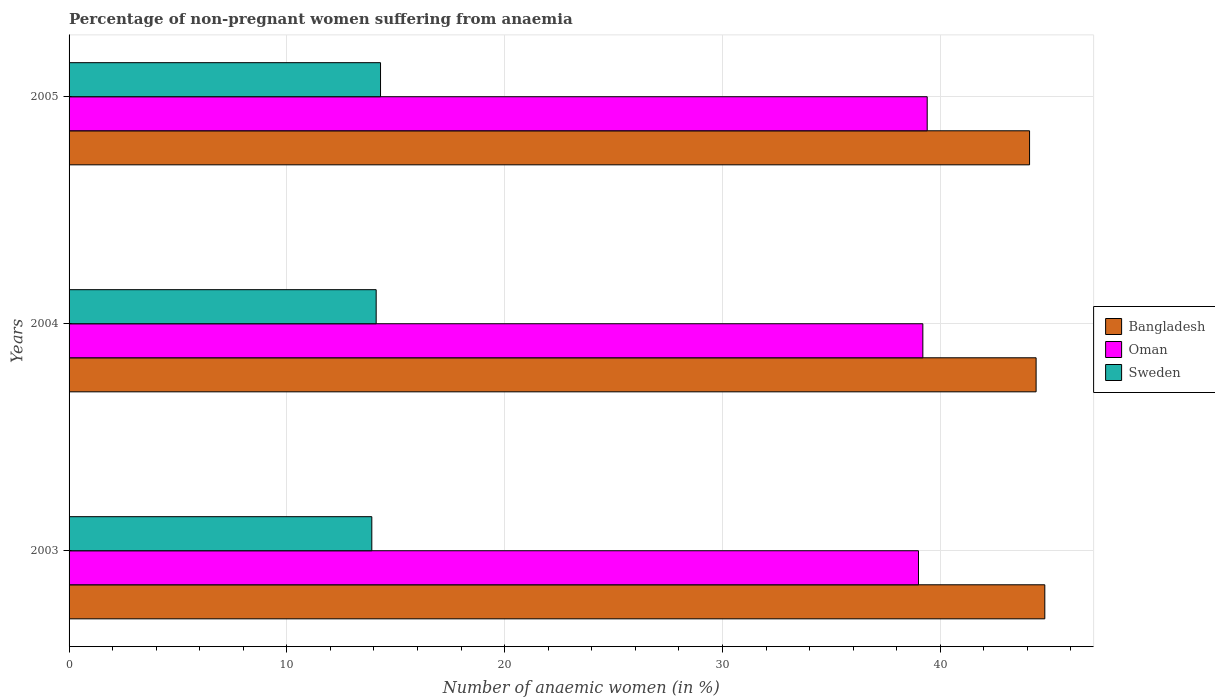Are the number of bars per tick equal to the number of legend labels?
Provide a short and direct response. Yes. How many bars are there on the 3rd tick from the bottom?
Keep it short and to the point. 3. In how many cases, is the number of bars for a given year not equal to the number of legend labels?
Keep it short and to the point. 0. What is the percentage of non-pregnant women suffering from anaemia in Oman in 2004?
Provide a succinct answer. 39.2. Across all years, what is the maximum percentage of non-pregnant women suffering from anaemia in Sweden?
Offer a very short reply. 14.3. In which year was the percentage of non-pregnant women suffering from anaemia in Sweden maximum?
Offer a very short reply. 2005. In which year was the percentage of non-pregnant women suffering from anaemia in Sweden minimum?
Provide a short and direct response. 2003. What is the total percentage of non-pregnant women suffering from anaemia in Bangladesh in the graph?
Your answer should be very brief. 133.3. What is the difference between the percentage of non-pregnant women suffering from anaemia in Bangladesh in 2003 and that in 2004?
Make the answer very short. 0.4. What is the difference between the percentage of non-pregnant women suffering from anaemia in Bangladesh in 2005 and the percentage of non-pregnant women suffering from anaemia in Sweden in 2003?
Provide a short and direct response. 30.2. What is the average percentage of non-pregnant women suffering from anaemia in Bangladesh per year?
Give a very brief answer. 44.43. In the year 2005, what is the difference between the percentage of non-pregnant women suffering from anaemia in Sweden and percentage of non-pregnant women suffering from anaemia in Bangladesh?
Provide a short and direct response. -29.8. In how many years, is the percentage of non-pregnant women suffering from anaemia in Oman greater than 10 %?
Your answer should be very brief. 3. What is the ratio of the percentage of non-pregnant women suffering from anaemia in Sweden in 2003 to that in 2005?
Keep it short and to the point. 0.97. Is the difference between the percentage of non-pregnant women suffering from anaemia in Sweden in 2004 and 2005 greater than the difference between the percentage of non-pregnant women suffering from anaemia in Bangladesh in 2004 and 2005?
Provide a succinct answer. No. What is the difference between the highest and the second highest percentage of non-pregnant women suffering from anaemia in Bangladesh?
Make the answer very short. 0.4. What is the difference between the highest and the lowest percentage of non-pregnant women suffering from anaemia in Oman?
Provide a succinct answer. 0.4. Is the sum of the percentage of non-pregnant women suffering from anaemia in Oman in 2003 and 2005 greater than the maximum percentage of non-pregnant women suffering from anaemia in Bangladesh across all years?
Ensure brevity in your answer.  Yes. What does the 1st bar from the bottom in 2003 represents?
Offer a terse response. Bangladesh. Are all the bars in the graph horizontal?
Give a very brief answer. Yes. Are the values on the major ticks of X-axis written in scientific E-notation?
Offer a terse response. No. Does the graph contain any zero values?
Ensure brevity in your answer.  No. What is the title of the graph?
Offer a very short reply. Percentage of non-pregnant women suffering from anaemia. Does "Andorra" appear as one of the legend labels in the graph?
Your answer should be very brief. No. What is the label or title of the X-axis?
Provide a short and direct response. Number of anaemic women (in %). What is the label or title of the Y-axis?
Your answer should be compact. Years. What is the Number of anaemic women (in %) in Bangladesh in 2003?
Ensure brevity in your answer.  44.8. What is the Number of anaemic women (in %) of Oman in 2003?
Your answer should be compact. 39. What is the Number of anaemic women (in %) in Sweden in 2003?
Give a very brief answer. 13.9. What is the Number of anaemic women (in %) in Bangladesh in 2004?
Your response must be concise. 44.4. What is the Number of anaemic women (in %) in Oman in 2004?
Your response must be concise. 39.2. What is the Number of anaemic women (in %) of Sweden in 2004?
Your response must be concise. 14.1. What is the Number of anaemic women (in %) in Bangladesh in 2005?
Your answer should be very brief. 44.1. What is the Number of anaemic women (in %) of Oman in 2005?
Provide a succinct answer. 39.4. What is the Number of anaemic women (in %) of Sweden in 2005?
Your answer should be very brief. 14.3. Across all years, what is the maximum Number of anaemic women (in %) in Bangladesh?
Provide a succinct answer. 44.8. Across all years, what is the maximum Number of anaemic women (in %) of Oman?
Provide a short and direct response. 39.4. Across all years, what is the minimum Number of anaemic women (in %) in Bangladesh?
Your response must be concise. 44.1. Across all years, what is the minimum Number of anaemic women (in %) of Oman?
Provide a succinct answer. 39. Across all years, what is the minimum Number of anaemic women (in %) of Sweden?
Offer a very short reply. 13.9. What is the total Number of anaemic women (in %) of Bangladesh in the graph?
Your answer should be compact. 133.3. What is the total Number of anaemic women (in %) of Oman in the graph?
Give a very brief answer. 117.6. What is the total Number of anaemic women (in %) of Sweden in the graph?
Keep it short and to the point. 42.3. What is the difference between the Number of anaemic women (in %) in Bangladesh in 2003 and that in 2004?
Provide a short and direct response. 0.4. What is the difference between the Number of anaemic women (in %) of Bangladesh in 2003 and that in 2005?
Keep it short and to the point. 0.7. What is the difference between the Number of anaemic women (in %) of Oman in 2003 and that in 2005?
Your response must be concise. -0.4. What is the difference between the Number of anaemic women (in %) of Sweden in 2003 and that in 2005?
Make the answer very short. -0.4. What is the difference between the Number of anaemic women (in %) of Bangladesh in 2003 and the Number of anaemic women (in %) of Sweden in 2004?
Offer a very short reply. 30.7. What is the difference between the Number of anaemic women (in %) of Oman in 2003 and the Number of anaemic women (in %) of Sweden in 2004?
Ensure brevity in your answer.  24.9. What is the difference between the Number of anaemic women (in %) in Bangladesh in 2003 and the Number of anaemic women (in %) in Oman in 2005?
Give a very brief answer. 5.4. What is the difference between the Number of anaemic women (in %) in Bangladesh in 2003 and the Number of anaemic women (in %) in Sweden in 2005?
Your answer should be compact. 30.5. What is the difference between the Number of anaemic women (in %) of Oman in 2003 and the Number of anaemic women (in %) of Sweden in 2005?
Offer a terse response. 24.7. What is the difference between the Number of anaemic women (in %) of Bangladesh in 2004 and the Number of anaemic women (in %) of Oman in 2005?
Keep it short and to the point. 5. What is the difference between the Number of anaemic women (in %) in Bangladesh in 2004 and the Number of anaemic women (in %) in Sweden in 2005?
Provide a short and direct response. 30.1. What is the difference between the Number of anaemic women (in %) of Oman in 2004 and the Number of anaemic women (in %) of Sweden in 2005?
Your answer should be very brief. 24.9. What is the average Number of anaemic women (in %) of Bangladesh per year?
Your response must be concise. 44.43. What is the average Number of anaemic women (in %) of Oman per year?
Your response must be concise. 39.2. In the year 2003, what is the difference between the Number of anaemic women (in %) of Bangladesh and Number of anaemic women (in %) of Sweden?
Your answer should be very brief. 30.9. In the year 2003, what is the difference between the Number of anaemic women (in %) of Oman and Number of anaemic women (in %) of Sweden?
Your answer should be compact. 25.1. In the year 2004, what is the difference between the Number of anaemic women (in %) of Bangladesh and Number of anaemic women (in %) of Oman?
Offer a very short reply. 5.2. In the year 2004, what is the difference between the Number of anaemic women (in %) of Bangladesh and Number of anaemic women (in %) of Sweden?
Your answer should be very brief. 30.3. In the year 2004, what is the difference between the Number of anaemic women (in %) of Oman and Number of anaemic women (in %) of Sweden?
Offer a very short reply. 25.1. In the year 2005, what is the difference between the Number of anaemic women (in %) in Bangladesh and Number of anaemic women (in %) in Sweden?
Offer a very short reply. 29.8. In the year 2005, what is the difference between the Number of anaemic women (in %) in Oman and Number of anaemic women (in %) in Sweden?
Ensure brevity in your answer.  25.1. What is the ratio of the Number of anaemic women (in %) of Sweden in 2003 to that in 2004?
Your answer should be compact. 0.99. What is the ratio of the Number of anaemic women (in %) of Bangladesh in 2003 to that in 2005?
Your answer should be compact. 1.02. What is the ratio of the Number of anaemic women (in %) of Sweden in 2003 to that in 2005?
Provide a succinct answer. 0.97. What is the ratio of the Number of anaemic women (in %) of Bangladesh in 2004 to that in 2005?
Your response must be concise. 1.01. What is the ratio of the Number of anaemic women (in %) in Sweden in 2004 to that in 2005?
Keep it short and to the point. 0.99. What is the difference between the highest and the lowest Number of anaemic women (in %) in Bangladesh?
Your answer should be compact. 0.7. What is the difference between the highest and the lowest Number of anaemic women (in %) of Sweden?
Keep it short and to the point. 0.4. 